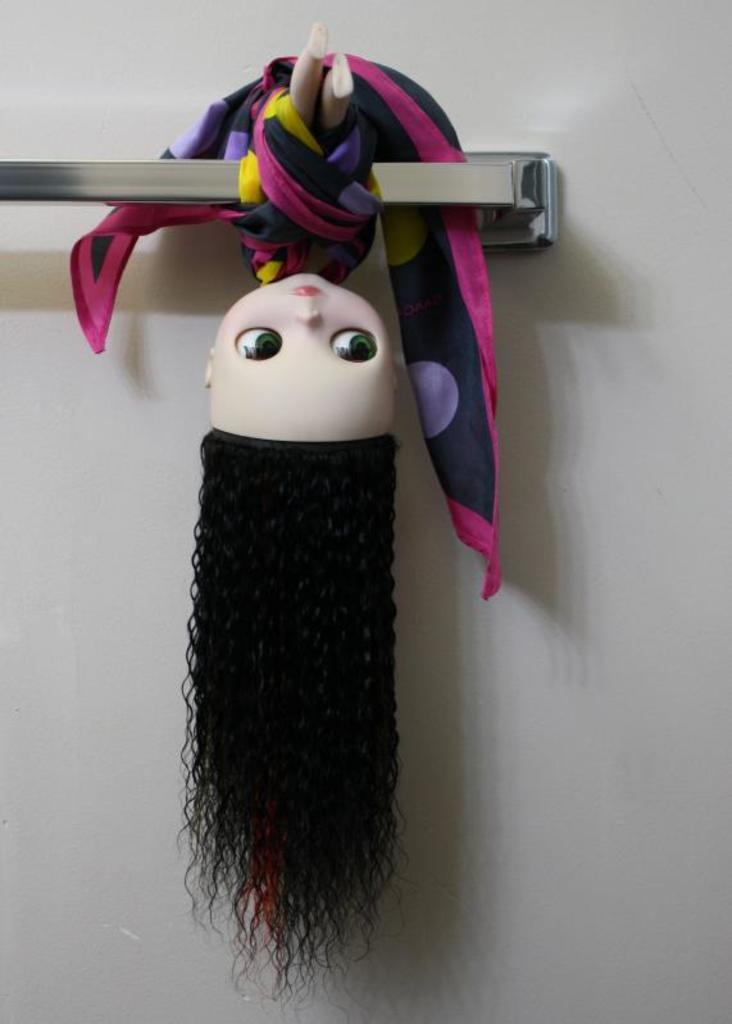What is the main subject in the image? There is a doll in the image. How is the doll positioned in the image? The doll is hanged from a rod. Where is the rod located in the image? The rod is in the center of the image. What type of bed is visible in the image? There is no bed present in the image; it features a doll hanged from a rod. How much payment is required to purchase the zebra in the image? There is no zebra present in the image, and therefore no payment is required. 